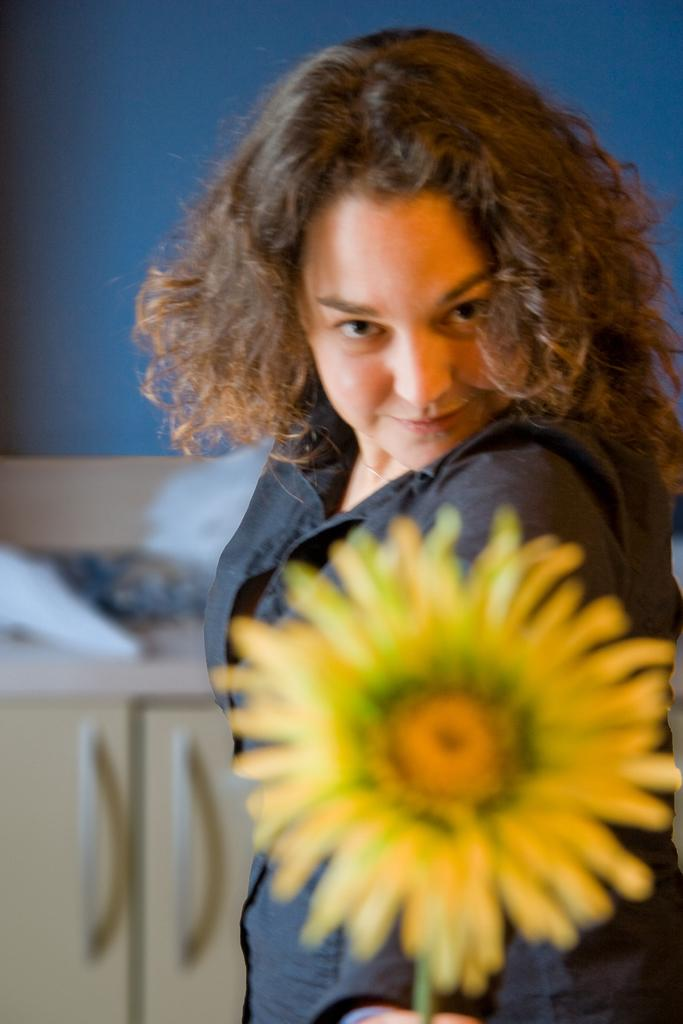Who is present in the image? There is a woman in the image. What is the woman wearing? The woman is wearing a black dress. What is the woman holding in the image? The woman is holding a sunflower. What can be seen in the background of the image? There is a table in the image. What is placed on the table? There are objects placed on the table. How many ducks are swimming in the water near the woman in the image? There are no ducks present in the image. What type of step is visible in the image? There is no step visible in the image. 